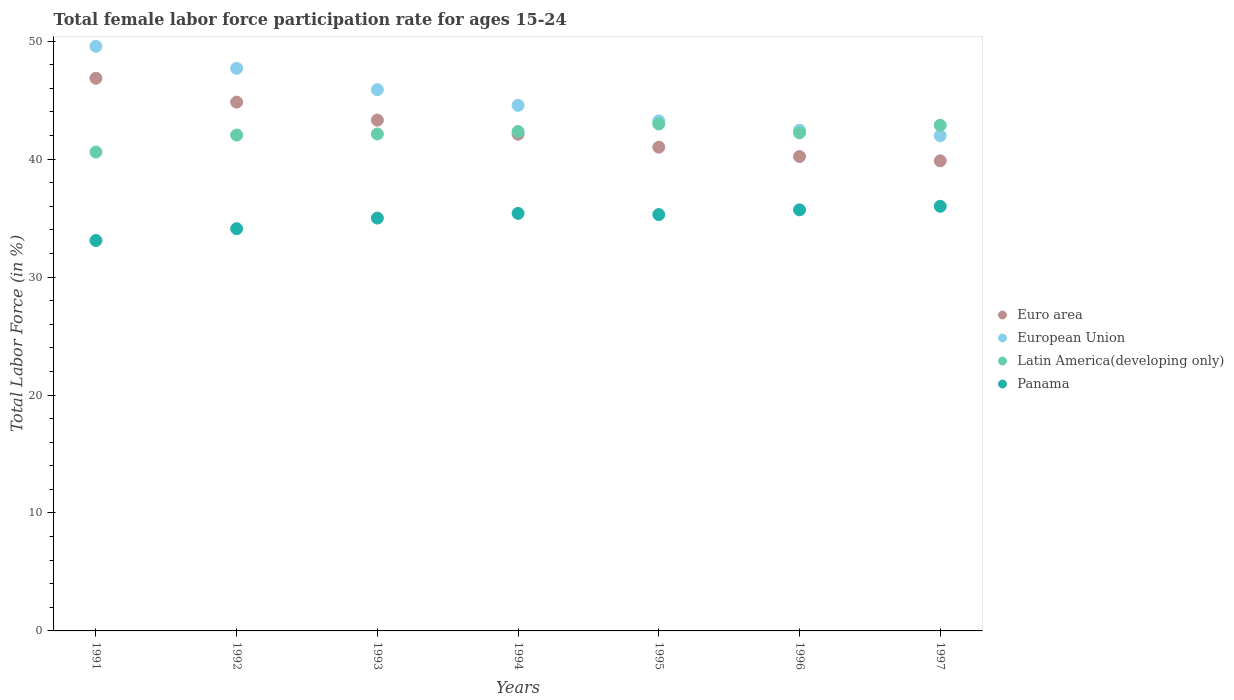How many different coloured dotlines are there?
Your answer should be compact. 4. What is the female labor force participation rate in Latin America(developing only) in 1994?
Your answer should be compact. 42.34. Across all years, what is the maximum female labor force participation rate in Panama?
Ensure brevity in your answer.  36. Across all years, what is the minimum female labor force participation rate in European Union?
Make the answer very short. 41.99. In which year was the female labor force participation rate in Latin America(developing only) maximum?
Offer a terse response. 1995. What is the total female labor force participation rate in Latin America(developing only) in the graph?
Offer a terse response. 295.19. What is the difference between the female labor force participation rate in Euro area in 1993 and that in 1995?
Provide a short and direct response. 2.3. What is the difference between the female labor force participation rate in Latin America(developing only) in 1992 and the female labor force participation rate in Panama in 1995?
Provide a short and direct response. 6.74. What is the average female labor force participation rate in Latin America(developing only) per year?
Ensure brevity in your answer.  42.17. In the year 1991, what is the difference between the female labor force participation rate in Euro area and female labor force participation rate in Panama?
Keep it short and to the point. 13.76. What is the ratio of the female labor force participation rate in Euro area in 1993 to that in 1994?
Offer a very short reply. 1.03. Is the difference between the female labor force participation rate in Euro area in 1992 and 1996 greater than the difference between the female labor force participation rate in Panama in 1992 and 1996?
Ensure brevity in your answer.  Yes. What is the difference between the highest and the second highest female labor force participation rate in Latin America(developing only)?
Provide a succinct answer. 0.11. What is the difference between the highest and the lowest female labor force participation rate in Latin America(developing only)?
Provide a short and direct response. 2.38. Is it the case that in every year, the sum of the female labor force participation rate in Latin America(developing only) and female labor force participation rate in Panama  is greater than the female labor force participation rate in European Union?
Make the answer very short. Yes. How many dotlines are there?
Your answer should be compact. 4. How many years are there in the graph?
Provide a succinct answer. 7. What is the difference between two consecutive major ticks on the Y-axis?
Give a very brief answer. 10. Does the graph contain grids?
Give a very brief answer. No. Where does the legend appear in the graph?
Provide a succinct answer. Center right. What is the title of the graph?
Offer a terse response. Total female labor force participation rate for ages 15-24. Does "Turkey" appear as one of the legend labels in the graph?
Your answer should be compact. No. What is the Total Labor Force (in %) in Euro area in 1991?
Your response must be concise. 46.86. What is the Total Labor Force (in %) in European Union in 1991?
Provide a short and direct response. 49.57. What is the Total Labor Force (in %) in Latin America(developing only) in 1991?
Ensure brevity in your answer.  40.6. What is the Total Labor Force (in %) in Panama in 1991?
Offer a terse response. 33.1. What is the Total Labor Force (in %) in Euro area in 1992?
Your answer should be very brief. 44.83. What is the Total Labor Force (in %) of European Union in 1992?
Give a very brief answer. 47.7. What is the Total Labor Force (in %) of Latin America(developing only) in 1992?
Keep it short and to the point. 42.04. What is the Total Labor Force (in %) in Panama in 1992?
Your answer should be very brief. 34.1. What is the Total Labor Force (in %) in Euro area in 1993?
Give a very brief answer. 43.31. What is the Total Labor Force (in %) of European Union in 1993?
Your answer should be compact. 45.89. What is the Total Labor Force (in %) of Latin America(developing only) in 1993?
Give a very brief answer. 42.13. What is the Total Labor Force (in %) in Euro area in 1994?
Offer a very short reply. 42.11. What is the Total Labor Force (in %) of European Union in 1994?
Provide a succinct answer. 44.56. What is the Total Labor Force (in %) in Latin America(developing only) in 1994?
Ensure brevity in your answer.  42.34. What is the Total Labor Force (in %) in Panama in 1994?
Make the answer very short. 35.4. What is the Total Labor Force (in %) of Euro area in 1995?
Provide a succinct answer. 41.01. What is the Total Labor Force (in %) of European Union in 1995?
Ensure brevity in your answer.  43.24. What is the Total Labor Force (in %) of Latin America(developing only) in 1995?
Give a very brief answer. 42.98. What is the Total Labor Force (in %) of Panama in 1995?
Keep it short and to the point. 35.3. What is the Total Labor Force (in %) in Euro area in 1996?
Your response must be concise. 40.22. What is the Total Labor Force (in %) in European Union in 1996?
Your answer should be very brief. 42.45. What is the Total Labor Force (in %) in Latin America(developing only) in 1996?
Offer a very short reply. 42.23. What is the Total Labor Force (in %) in Panama in 1996?
Offer a terse response. 35.7. What is the Total Labor Force (in %) of Euro area in 1997?
Provide a succinct answer. 39.86. What is the Total Labor Force (in %) of European Union in 1997?
Your answer should be compact. 41.99. What is the Total Labor Force (in %) of Latin America(developing only) in 1997?
Provide a short and direct response. 42.87. What is the Total Labor Force (in %) of Panama in 1997?
Provide a succinct answer. 36. Across all years, what is the maximum Total Labor Force (in %) of Euro area?
Ensure brevity in your answer.  46.86. Across all years, what is the maximum Total Labor Force (in %) of European Union?
Make the answer very short. 49.57. Across all years, what is the maximum Total Labor Force (in %) of Latin America(developing only)?
Your answer should be compact. 42.98. Across all years, what is the minimum Total Labor Force (in %) of Euro area?
Provide a short and direct response. 39.86. Across all years, what is the minimum Total Labor Force (in %) in European Union?
Make the answer very short. 41.99. Across all years, what is the minimum Total Labor Force (in %) in Latin America(developing only)?
Your answer should be compact. 40.6. Across all years, what is the minimum Total Labor Force (in %) in Panama?
Your answer should be very brief. 33.1. What is the total Total Labor Force (in %) in Euro area in the graph?
Keep it short and to the point. 298.19. What is the total Total Labor Force (in %) in European Union in the graph?
Make the answer very short. 315.39. What is the total Total Labor Force (in %) in Latin America(developing only) in the graph?
Ensure brevity in your answer.  295.19. What is the total Total Labor Force (in %) in Panama in the graph?
Give a very brief answer. 244.6. What is the difference between the Total Labor Force (in %) in Euro area in 1991 and that in 1992?
Provide a succinct answer. 2.02. What is the difference between the Total Labor Force (in %) in European Union in 1991 and that in 1992?
Your response must be concise. 1.87. What is the difference between the Total Labor Force (in %) of Latin America(developing only) in 1991 and that in 1992?
Your response must be concise. -1.44. What is the difference between the Total Labor Force (in %) in Euro area in 1991 and that in 1993?
Your response must be concise. 3.55. What is the difference between the Total Labor Force (in %) of European Union in 1991 and that in 1993?
Provide a succinct answer. 3.68. What is the difference between the Total Labor Force (in %) of Latin America(developing only) in 1991 and that in 1993?
Keep it short and to the point. -1.53. What is the difference between the Total Labor Force (in %) of Euro area in 1991 and that in 1994?
Your answer should be very brief. 4.74. What is the difference between the Total Labor Force (in %) in European Union in 1991 and that in 1994?
Keep it short and to the point. 5.01. What is the difference between the Total Labor Force (in %) of Latin America(developing only) in 1991 and that in 1994?
Provide a succinct answer. -1.74. What is the difference between the Total Labor Force (in %) of Panama in 1991 and that in 1994?
Provide a short and direct response. -2.3. What is the difference between the Total Labor Force (in %) in Euro area in 1991 and that in 1995?
Ensure brevity in your answer.  5.84. What is the difference between the Total Labor Force (in %) in European Union in 1991 and that in 1995?
Offer a very short reply. 6.33. What is the difference between the Total Labor Force (in %) of Latin America(developing only) in 1991 and that in 1995?
Offer a very short reply. -2.38. What is the difference between the Total Labor Force (in %) in Euro area in 1991 and that in 1996?
Keep it short and to the point. 6.64. What is the difference between the Total Labor Force (in %) in European Union in 1991 and that in 1996?
Your response must be concise. 7.11. What is the difference between the Total Labor Force (in %) of Latin America(developing only) in 1991 and that in 1996?
Offer a very short reply. -1.63. What is the difference between the Total Labor Force (in %) in Euro area in 1991 and that in 1997?
Offer a terse response. 7. What is the difference between the Total Labor Force (in %) of European Union in 1991 and that in 1997?
Your answer should be very brief. 7.58. What is the difference between the Total Labor Force (in %) of Latin America(developing only) in 1991 and that in 1997?
Give a very brief answer. -2.27. What is the difference between the Total Labor Force (in %) in Euro area in 1992 and that in 1993?
Your answer should be very brief. 1.52. What is the difference between the Total Labor Force (in %) of European Union in 1992 and that in 1993?
Offer a very short reply. 1.81. What is the difference between the Total Labor Force (in %) of Latin America(developing only) in 1992 and that in 1993?
Keep it short and to the point. -0.09. What is the difference between the Total Labor Force (in %) in Panama in 1992 and that in 1993?
Your response must be concise. -0.9. What is the difference between the Total Labor Force (in %) of Euro area in 1992 and that in 1994?
Ensure brevity in your answer.  2.72. What is the difference between the Total Labor Force (in %) in European Union in 1992 and that in 1994?
Ensure brevity in your answer.  3.14. What is the difference between the Total Labor Force (in %) of Latin America(developing only) in 1992 and that in 1994?
Make the answer very short. -0.3. What is the difference between the Total Labor Force (in %) of Panama in 1992 and that in 1994?
Your answer should be compact. -1.3. What is the difference between the Total Labor Force (in %) in Euro area in 1992 and that in 1995?
Your response must be concise. 3.82. What is the difference between the Total Labor Force (in %) of European Union in 1992 and that in 1995?
Give a very brief answer. 4.46. What is the difference between the Total Labor Force (in %) of Latin America(developing only) in 1992 and that in 1995?
Make the answer very short. -0.94. What is the difference between the Total Labor Force (in %) in Panama in 1992 and that in 1995?
Ensure brevity in your answer.  -1.2. What is the difference between the Total Labor Force (in %) in Euro area in 1992 and that in 1996?
Provide a short and direct response. 4.61. What is the difference between the Total Labor Force (in %) of European Union in 1992 and that in 1996?
Your response must be concise. 5.24. What is the difference between the Total Labor Force (in %) in Latin America(developing only) in 1992 and that in 1996?
Ensure brevity in your answer.  -0.19. What is the difference between the Total Labor Force (in %) in Panama in 1992 and that in 1996?
Your response must be concise. -1.6. What is the difference between the Total Labor Force (in %) of Euro area in 1992 and that in 1997?
Keep it short and to the point. 4.97. What is the difference between the Total Labor Force (in %) of European Union in 1992 and that in 1997?
Keep it short and to the point. 5.71. What is the difference between the Total Labor Force (in %) of Latin America(developing only) in 1992 and that in 1997?
Offer a very short reply. -0.83. What is the difference between the Total Labor Force (in %) in Euro area in 1993 and that in 1994?
Provide a short and direct response. 1.19. What is the difference between the Total Labor Force (in %) in European Union in 1993 and that in 1994?
Your answer should be compact. 1.33. What is the difference between the Total Labor Force (in %) in Latin America(developing only) in 1993 and that in 1994?
Your answer should be very brief. -0.21. What is the difference between the Total Labor Force (in %) in Panama in 1993 and that in 1994?
Offer a very short reply. -0.4. What is the difference between the Total Labor Force (in %) in Euro area in 1993 and that in 1995?
Keep it short and to the point. 2.29. What is the difference between the Total Labor Force (in %) of European Union in 1993 and that in 1995?
Offer a terse response. 2.65. What is the difference between the Total Labor Force (in %) of Latin America(developing only) in 1993 and that in 1995?
Give a very brief answer. -0.85. What is the difference between the Total Labor Force (in %) of Euro area in 1993 and that in 1996?
Provide a succinct answer. 3.09. What is the difference between the Total Labor Force (in %) of European Union in 1993 and that in 1996?
Provide a succinct answer. 3.43. What is the difference between the Total Labor Force (in %) in Latin America(developing only) in 1993 and that in 1996?
Keep it short and to the point. -0.1. What is the difference between the Total Labor Force (in %) in Euro area in 1993 and that in 1997?
Ensure brevity in your answer.  3.45. What is the difference between the Total Labor Force (in %) in European Union in 1993 and that in 1997?
Your answer should be very brief. 3.9. What is the difference between the Total Labor Force (in %) in Latin America(developing only) in 1993 and that in 1997?
Ensure brevity in your answer.  -0.74. What is the difference between the Total Labor Force (in %) of Panama in 1993 and that in 1997?
Your answer should be compact. -1. What is the difference between the Total Labor Force (in %) in Euro area in 1994 and that in 1995?
Offer a terse response. 1.1. What is the difference between the Total Labor Force (in %) of European Union in 1994 and that in 1995?
Your response must be concise. 1.32. What is the difference between the Total Labor Force (in %) of Latin America(developing only) in 1994 and that in 1995?
Your answer should be compact. -0.64. What is the difference between the Total Labor Force (in %) of Panama in 1994 and that in 1995?
Provide a succinct answer. 0.1. What is the difference between the Total Labor Force (in %) of Euro area in 1994 and that in 1996?
Provide a succinct answer. 1.9. What is the difference between the Total Labor Force (in %) of European Union in 1994 and that in 1996?
Provide a short and direct response. 2.11. What is the difference between the Total Labor Force (in %) in Latin America(developing only) in 1994 and that in 1996?
Provide a succinct answer. 0.11. What is the difference between the Total Labor Force (in %) in Panama in 1994 and that in 1996?
Provide a succinct answer. -0.3. What is the difference between the Total Labor Force (in %) of Euro area in 1994 and that in 1997?
Give a very brief answer. 2.26. What is the difference between the Total Labor Force (in %) of European Union in 1994 and that in 1997?
Offer a very short reply. 2.57. What is the difference between the Total Labor Force (in %) of Latin America(developing only) in 1994 and that in 1997?
Keep it short and to the point. -0.53. What is the difference between the Total Labor Force (in %) in Panama in 1994 and that in 1997?
Offer a terse response. -0.6. What is the difference between the Total Labor Force (in %) in Euro area in 1995 and that in 1996?
Offer a very short reply. 0.79. What is the difference between the Total Labor Force (in %) of European Union in 1995 and that in 1996?
Offer a very short reply. 0.79. What is the difference between the Total Labor Force (in %) in Latin America(developing only) in 1995 and that in 1996?
Give a very brief answer. 0.75. What is the difference between the Total Labor Force (in %) in Euro area in 1995 and that in 1997?
Ensure brevity in your answer.  1.15. What is the difference between the Total Labor Force (in %) in European Union in 1995 and that in 1997?
Your answer should be compact. 1.25. What is the difference between the Total Labor Force (in %) in Latin America(developing only) in 1995 and that in 1997?
Keep it short and to the point. 0.11. What is the difference between the Total Labor Force (in %) of Panama in 1995 and that in 1997?
Give a very brief answer. -0.7. What is the difference between the Total Labor Force (in %) in Euro area in 1996 and that in 1997?
Offer a very short reply. 0.36. What is the difference between the Total Labor Force (in %) in European Union in 1996 and that in 1997?
Offer a terse response. 0.46. What is the difference between the Total Labor Force (in %) of Latin America(developing only) in 1996 and that in 1997?
Your answer should be very brief. -0.64. What is the difference between the Total Labor Force (in %) of Euro area in 1991 and the Total Labor Force (in %) of European Union in 1992?
Provide a succinct answer. -0.84. What is the difference between the Total Labor Force (in %) in Euro area in 1991 and the Total Labor Force (in %) in Latin America(developing only) in 1992?
Offer a terse response. 4.82. What is the difference between the Total Labor Force (in %) of Euro area in 1991 and the Total Labor Force (in %) of Panama in 1992?
Provide a short and direct response. 12.76. What is the difference between the Total Labor Force (in %) of European Union in 1991 and the Total Labor Force (in %) of Latin America(developing only) in 1992?
Ensure brevity in your answer.  7.53. What is the difference between the Total Labor Force (in %) in European Union in 1991 and the Total Labor Force (in %) in Panama in 1992?
Ensure brevity in your answer.  15.47. What is the difference between the Total Labor Force (in %) in Latin America(developing only) in 1991 and the Total Labor Force (in %) in Panama in 1992?
Make the answer very short. 6.5. What is the difference between the Total Labor Force (in %) of Euro area in 1991 and the Total Labor Force (in %) of European Union in 1993?
Your response must be concise. 0.97. What is the difference between the Total Labor Force (in %) in Euro area in 1991 and the Total Labor Force (in %) in Latin America(developing only) in 1993?
Your response must be concise. 4.72. What is the difference between the Total Labor Force (in %) of Euro area in 1991 and the Total Labor Force (in %) of Panama in 1993?
Your response must be concise. 11.86. What is the difference between the Total Labor Force (in %) of European Union in 1991 and the Total Labor Force (in %) of Latin America(developing only) in 1993?
Offer a terse response. 7.43. What is the difference between the Total Labor Force (in %) of European Union in 1991 and the Total Labor Force (in %) of Panama in 1993?
Make the answer very short. 14.57. What is the difference between the Total Labor Force (in %) of Latin America(developing only) in 1991 and the Total Labor Force (in %) of Panama in 1993?
Offer a terse response. 5.6. What is the difference between the Total Labor Force (in %) of Euro area in 1991 and the Total Labor Force (in %) of European Union in 1994?
Your answer should be very brief. 2.3. What is the difference between the Total Labor Force (in %) of Euro area in 1991 and the Total Labor Force (in %) of Latin America(developing only) in 1994?
Offer a terse response. 4.52. What is the difference between the Total Labor Force (in %) of Euro area in 1991 and the Total Labor Force (in %) of Panama in 1994?
Give a very brief answer. 11.46. What is the difference between the Total Labor Force (in %) of European Union in 1991 and the Total Labor Force (in %) of Latin America(developing only) in 1994?
Give a very brief answer. 7.23. What is the difference between the Total Labor Force (in %) in European Union in 1991 and the Total Labor Force (in %) in Panama in 1994?
Offer a terse response. 14.17. What is the difference between the Total Labor Force (in %) in Latin America(developing only) in 1991 and the Total Labor Force (in %) in Panama in 1994?
Provide a succinct answer. 5.2. What is the difference between the Total Labor Force (in %) of Euro area in 1991 and the Total Labor Force (in %) of European Union in 1995?
Your response must be concise. 3.62. What is the difference between the Total Labor Force (in %) of Euro area in 1991 and the Total Labor Force (in %) of Latin America(developing only) in 1995?
Give a very brief answer. 3.88. What is the difference between the Total Labor Force (in %) of Euro area in 1991 and the Total Labor Force (in %) of Panama in 1995?
Offer a terse response. 11.56. What is the difference between the Total Labor Force (in %) in European Union in 1991 and the Total Labor Force (in %) in Latin America(developing only) in 1995?
Your answer should be very brief. 6.59. What is the difference between the Total Labor Force (in %) of European Union in 1991 and the Total Labor Force (in %) of Panama in 1995?
Ensure brevity in your answer.  14.27. What is the difference between the Total Labor Force (in %) in Latin America(developing only) in 1991 and the Total Labor Force (in %) in Panama in 1995?
Provide a short and direct response. 5.3. What is the difference between the Total Labor Force (in %) in Euro area in 1991 and the Total Labor Force (in %) in European Union in 1996?
Give a very brief answer. 4.4. What is the difference between the Total Labor Force (in %) of Euro area in 1991 and the Total Labor Force (in %) of Latin America(developing only) in 1996?
Provide a short and direct response. 4.62. What is the difference between the Total Labor Force (in %) in Euro area in 1991 and the Total Labor Force (in %) in Panama in 1996?
Make the answer very short. 11.16. What is the difference between the Total Labor Force (in %) in European Union in 1991 and the Total Labor Force (in %) in Latin America(developing only) in 1996?
Your answer should be very brief. 7.33. What is the difference between the Total Labor Force (in %) of European Union in 1991 and the Total Labor Force (in %) of Panama in 1996?
Your answer should be compact. 13.87. What is the difference between the Total Labor Force (in %) of Latin America(developing only) in 1991 and the Total Labor Force (in %) of Panama in 1996?
Provide a short and direct response. 4.9. What is the difference between the Total Labor Force (in %) in Euro area in 1991 and the Total Labor Force (in %) in European Union in 1997?
Offer a very short reply. 4.87. What is the difference between the Total Labor Force (in %) in Euro area in 1991 and the Total Labor Force (in %) in Latin America(developing only) in 1997?
Offer a terse response. 3.98. What is the difference between the Total Labor Force (in %) of Euro area in 1991 and the Total Labor Force (in %) of Panama in 1997?
Your response must be concise. 10.86. What is the difference between the Total Labor Force (in %) in European Union in 1991 and the Total Labor Force (in %) in Latin America(developing only) in 1997?
Provide a succinct answer. 6.7. What is the difference between the Total Labor Force (in %) of European Union in 1991 and the Total Labor Force (in %) of Panama in 1997?
Offer a terse response. 13.57. What is the difference between the Total Labor Force (in %) of Latin America(developing only) in 1991 and the Total Labor Force (in %) of Panama in 1997?
Provide a short and direct response. 4.6. What is the difference between the Total Labor Force (in %) in Euro area in 1992 and the Total Labor Force (in %) in European Union in 1993?
Ensure brevity in your answer.  -1.06. What is the difference between the Total Labor Force (in %) in Euro area in 1992 and the Total Labor Force (in %) in Latin America(developing only) in 1993?
Ensure brevity in your answer.  2.7. What is the difference between the Total Labor Force (in %) of Euro area in 1992 and the Total Labor Force (in %) of Panama in 1993?
Your answer should be very brief. 9.83. What is the difference between the Total Labor Force (in %) in European Union in 1992 and the Total Labor Force (in %) in Latin America(developing only) in 1993?
Your response must be concise. 5.56. What is the difference between the Total Labor Force (in %) of European Union in 1992 and the Total Labor Force (in %) of Panama in 1993?
Keep it short and to the point. 12.7. What is the difference between the Total Labor Force (in %) in Latin America(developing only) in 1992 and the Total Labor Force (in %) in Panama in 1993?
Give a very brief answer. 7.04. What is the difference between the Total Labor Force (in %) in Euro area in 1992 and the Total Labor Force (in %) in European Union in 1994?
Give a very brief answer. 0.27. What is the difference between the Total Labor Force (in %) in Euro area in 1992 and the Total Labor Force (in %) in Latin America(developing only) in 1994?
Offer a very short reply. 2.49. What is the difference between the Total Labor Force (in %) in Euro area in 1992 and the Total Labor Force (in %) in Panama in 1994?
Make the answer very short. 9.43. What is the difference between the Total Labor Force (in %) in European Union in 1992 and the Total Labor Force (in %) in Latin America(developing only) in 1994?
Make the answer very short. 5.36. What is the difference between the Total Labor Force (in %) in European Union in 1992 and the Total Labor Force (in %) in Panama in 1994?
Provide a short and direct response. 12.3. What is the difference between the Total Labor Force (in %) of Latin America(developing only) in 1992 and the Total Labor Force (in %) of Panama in 1994?
Offer a very short reply. 6.64. What is the difference between the Total Labor Force (in %) of Euro area in 1992 and the Total Labor Force (in %) of European Union in 1995?
Your answer should be compact. 1.59. What is the difference between the Total Labor Force (in %) of Euro area in 1992 and the Total Labor Force (in %) of Latin America(developing only) in 1995?
Offer a very short reply. 1.85. What is the difference between the Total Labor Force (in %) in Euro area in 1992 and the Total Labor Force (in %) in Panama in 1995?
Your answer should be very brief. 9.53. What is the difference between the Total Labor Force (in %) in European Union in 1992 and the Total Labor Force (in %) in Latin America(developing only) in 1995?
Your response must be concise. 4.72. What is the difference between the Total Labor Force (in %) of European Union in 1992 and the Total Labor Force (in %) of Panama in 1995?
Provide a short and direct response. 12.4. What is the difference between the Total Labor Force (in %) of Latin America(developing only) in 1992 and the Total Labor Force (in %) of Panama in 1995?
Give a very brief answer. 6.74. What is the difference between the Total Labor Force (in %) in Euro area in 1992 and the Total Labor Force (in %) in European Union in 1996?
Your answer should be very brief. 2.38. What is the difference between the Total Labor Force (in %) in Euro area in 1992 and the Total Labor Force (in %) in Latin America(developing only) in 1996?
Offer a terse response. 2.6. What is the difference between the Total Labor Force (in %) in Euro area in 1992 and the Total Labor Force (in %) in Panama in 1996?
Your answer should be compact. 9.13. What is the difference between the Total Labor Force (in %) in European Union in 1992 and the Total Labor Force (in %) in Latin America(developing only) in 1996?
Offer a very short reply. 5.46. What is the difference between the Total Labor Force (in %) in European Union in 1992 and the Total Labor Force (in %) in Panama in 1996?
Offer a very short reply. 12. What is the difference between the Total Labor Force (in %) of Latin America(developing only) in 1992 and the Total Labor Force (in %) of Panama in 1996?
Ensure brevity in your answer.  6.34. What is the difference between the Total Labor Force (in %) of Euro area in 1992 and the Total Labor Force (in %) of European Union in 1997?
Your answer should be compact. 2.84. What is the difference between the Total Labor Force (in %) of Euro area in 1992 and the Total Labor Force (in %) of Latin America(developing only) in 1997?
Provide a short and direct response. 1.96. What is the difference between the Total Labor Force (in %) in Euro area in 1992 and the Total Labor Force (in %) in Panama in 1997?
Make the answer very short. 8.83. What is the difference between the Total Labor Force (in %) of European Union in 1992 and the Total Labor Force (in %) of Latin America(developing only) in 1997?
Give a very brief answer. 4.83. What is the difference between the Total Labor Force (in %) in European Union in 1992 and the Total Labor Force (in %) in Panama in 1997?
Your answer should be compact. 11.7. What is the difference between the Total Labor Force (in %) of Latin America(developing only) in 1992 and the Total Labor Force (in %) of Panama in 1997?
Your answer should be very brief. 6.04. What is the difference between the Total Labor Force (in %) of Euro area in 1993 and the Total Labor Force (in %) of European Union in 1994?
Your response must be concise. -1.25. What is the difference between the Total Labor Force (in %) in Euro area in 1993 and the Total Labor Force (in %) in Latin America(developing only) in 1994?
Provide a short and direct response. 0.97. What is the difference between the Total Labor Force (in %) of Euro area in 1993 and the Total Labor Force (in %) of Panama in 1994?
Keep it short and to the point. 7.91. What is the difference between the Total Labor Force (in %) in European Union in 1993 and the Total Labor Force (in %) in Latin America(developing only) in 1994?
Make the answer very short. 3.55. What is the difference between the Total Labor Force (in %) in European Union in 1993 and the Total Labor Force (in %) in Panama in 1994?
Provide a short and direct response. 10.49. What is the difference between the Total Labor Force (in %) of Latin America(developing only) in 1993 and the Total Labor Force (in %) of Panama in 1994?
Your answer should be very brief. 6.73. What is the difference between the Total Labor Force (in %) of Euro area in 1993 and the Total Labor Force (in %) of European Union in 1995?
Make the answer very short. 0.07. What is the difference between the Total Labor Force (in %) of Euro area in 1993 and the Total Labor Force (in %) of Latin America(developing only) in 1995?
Provide a succinct answer. 0.33. What is the difference between the Total Labor Force (in %) in Euro area in 1993 and the Total Labor Force (in %) in Panama in 1995?
Your answer should be very brief. 8.01. What is the difference between the Total Labor Force (in %) in European Union in 1993 and the Total Labor Force (in %) in Latin America(developing only) in 1995?
Offer a very short reply. 2.91. What is the difference between the Total Labor Force (in %) in European Union in 1993 and the Total Labor Force (in %) in Panama in 1995?
Ensure brevity in your answer.  10.59. What is the difference between the Total Labor Force (in %) of Latin America(developing only) in 1993 and the Total Labor Force (in %) of Panama in 1995?
Give a very brief answer. 6.83. What is the difference between the Total Labor Force (in %) of Euro area in 1993 and the Total Labor Force (in %) of European Union in 1996?
Provide a short and direct response. 0.85. What is the difference between the Total Labor Force (in %) of Euro area in 1993 and the Total Labor Force (in %) of Latin America(developing only) in 1996?
Your response must be concise. 1.07. What is the difference between the Total Labor Force (in %) of Euro area in 1993 and the Total Labor Force (in %) of Panama in 1996?
Provide a succinct answer. 7.61. What is the difference between the Total Labor Force (in %) in European Union in 1993 and the Total Labor Force (in %) in Latin America(developing only) in 1996?
Your response must be concise. 3.65. What is the difference between the Total Labor Force (in %) of European Union in 1993 and the Total Labor Force (in %) of Panama in 1996?
Provide a short and direct response. 10.19. What is the difference between the Total Labor Force (in %) in Latin America(developing only) in 1993 and the Total Labor Force (in %) in Panama in 1996?
Offer a very short reply. 6.43. What is the difference between the Total Labor Force (in %) in Euro area in 1993 and the Total Labor Force (in %) in European Union in 1997?
Make the answer very short. 1.32. What is the difference between the Total Labor Force (in %) of Euro area in 1993 and the Total Labor Force (in %) of Latin America(developing only) in 1997?
Provide a short and direct response. 0.44. What is the difference between the Total Labor Force (in %) in Euro area in 1993 and the Total Labor Force (in %) in Panama in 1997?
Give a very brief answer. 7.31. What is the difference between the Total Labor Force (in %) in European Union in 1993 and the Total Labor Force (in %) in Latin America(developing only) in 1997?
Your answer should be very brief. 3.02. What is the difference between the Total Labor Force (in %) in European Union in 1993 and the Total Labor Force (in %) in Panama in 1997?
Keep it short and to the point. 9.89. What is the difference between the Total Labor Force (in %) in Latin America(developing only) in 1993 and the Total Labor Force (in %) in Panama in 1997?
Your answer should be compact. 6.13. What is the difference between the Total Labor Force (in %) of Euro area in 1994 and the Total Labor Force (in %) of European Union in 1995?
Make the answer very short. -1.12. What is the difference between the Total Labor Force (in %) in Euro area in 1994 and the Total Labor Force (in %) in Latin America(developing only) in 1995?
Keep it short and to the point. -0.87. What is the difference between the Total Labor Force (in %) in Euro area in 1994 and the Total Labor Force (in %) in Panama in 1995?
Offer a terse response. 6.81. What is the difference between the Total Labor Force (in %) of European Union in 1994 and the Total Labor Force (in %) of Latin America(developing only) in 1995?
Offer a terse response. 1.58. What is the difference between the Total Labor Force (in %) of European Union in 1994 and the Total Labor Force (in %) of Panama in 1995?
Ensure brevity in your answer.  9.26. What is the difference between the Total Labor Force (in %) in Latin America(developing only) in 1994 and the Total Labor Force (in %) in Panama in 1995?
Ensure brevity in your answer.  7.04. What is the difference between the Total Labor Force (in %) in Euro area in 1994 and the Total Labor Force (in %) in European Union in 1996?
Keep it short and to the point. -0.34. What is the difference between the Total Labor Force (in %) in Euro area in 1994 and the Total Labor Force (in %) in Latin America(developing only) in 1996?
Provide a succinct answer. -0.12. What is the difference between the Total Labor Force (in %) of Euro area in 1994 and the Total Labor Force (in %) of Panama in 1996?
Offer a very short reply. 6.41. What is the difference between the Total Labor Force (in %) in European Union in 1994 and the Total Labor Force (in %) in Latin America(developing only) in 1996?
Your answer should be compact. 2.33. What is the difference between the Total Labor Force (in %) of European Union in 1994 and the Total Labor Force (in %) of Panama in 1996?
Ensure brevity in your answer.  8.86. What is the difference between the Total Labor Force (in %) of Latin America(developing only) in 1994 and the Total Labor Force (in %) of Panama in 1996?
Provide a succinct answer. 6.64. What is the difference between the Total Labor Force (in %) in Euro area in 1994 and the Total Labor Force (in %) in European Union in 1997?
Your response must be concise. 0.12. What is the difference between the Total Labor Force (in %) in Euro area in 1994 and the Total Labor Force (in %) in Latin America(developing only) in 1997?
Offer a very short reply. -0.76. What is the difference between the Total Labor Force (in %) in Euro area in 1994 and the Total Labor Force (in %) in Panama in 1997?
Your answer should be compact. 6.11. What is the difference between the Total Labor Force (in %) in European Union in 1994 and the Total Labor Force (in %) in Latin America(developing only) in 1997?
Ensure brevity in your answer.  1.69. What is the difference between the Total Labor Force (in %) in European Union in 1994 and the Total Labor Force (in %) in Panama in 1997?
Offer a very short reply. 8.56. What is the difference between the Total Labor Force (in %) of Latin America(developing only) in 1994 and the Total Labor Force (in %) of Panama in 1997?
Offer a terse response. 6.34. What is the difference between the Total Labor Force (in %) in Euro area in 1995 and the Total Labor Force (in %) in European Union in 1996?
Provide a short and direct response. -1.44. What is the difference between the Total Labor Force (in %) of Euro area in 1995 and the Total Labor Force (in %) of Latin America(developing only) in 1996?
Keep it short and to the point. -1.22. What is the difference between the Total Labor Force (in %) in Euro area in 1995 and the Total Labor Force (in %) in Panama in 1996?
Make the answer very short. 5.31. What is the difference between the Total Labor Force (in %) of European Union in 1995 and the Total Labor Force (in %) of Latin America(developing only) in 1996?
Make the answer very short. 1.01. What is the difference between the Total Labor Force (in %) of European Union in 1995 and the Total Labor Force (in %) of Panama in 1996?
Keep it short and to the point. 7.54. What is the difference between the Total Labor Force (in %) in Latin America(developing only) in 1995 and the Total Labor Force (in %) in Panama in 1996?
Your response must be concise. 7.28. What is the difference between the Total Labor Force (in %) of Euro area in 1995 and the Total Labor Force (in %) of European Union in 1997?
Make the answer very short. -0.98. What is the difference between the Total Labor Force (in %) in Euro area in 1995 and the Total Labor Force (in %) in Latin America(developing only) in 1997?
Your response must be concise. -1.86. What is the difference between the Total Labor Force (in %) of Euro area in 1995 and the Total Labor Force (in %) of Panama in 1997?
Your answer should be compact. 5.01. What is the difference between the Total Labor Force (in %) in European Union in 1995 and the Total Labor Force (in %) in Latin America(developing only) in 1997?
Give a very brief answer. 0.37. What is the difference between the Total Labor Force (in %) in European Union in 1995 and the Total Labor Force (in %) in Panama in 1997?
Your answer should be very brief. 7.24. What is the difference between the Total Labor Force (in %) in Latin America(developing only) in 1995 and the Total Labor Force (in %) in Panama in 1997?
Offer a terse response. 6.98. What is the difference between the Total Labor Force (in %) in Euro area in 1996 and the Total Labor Force (in %) in European Union in 1997?
Ensure brevity in your answer.  -1.77. What is the difference between the Total Labor Force (in %) in Euro area in 1996 and the Total Labor Force (in %) in Latin America(developing only) in 1997?
Offer a terse response. -2.65. What is the difference between the Total Labor Force (in %) of Euro area in 1996 and the Total Labor Force (in %) of Panama in 1997?
Provide a succinct answer. 4.22. What is the difference between the Total Labor Force (in %) of European Union in 1996 and the Total Labor Force (in %) of Latin America(developing only) in 1997?
Provide a succinct answer. -0.42. What is the difference between the Total Labor Force (in %) of European Union in 1996 and the Total Labor Force (in %) of Panama in 1997?
Offer a very short reply. 6.45. What is the difference between the Total Labor Force (in %) of Latin America(developing only) in 1996 and the Total Labor Force (in %) of Panama in 1997?
Ensure brevity in your answer.  6.23. What is the average Total Labor Force (in %) of Euro area per year?
Give a very brief answer. 42.6. What is the average Total Labor Force (in %) of European Union per year?
Make the answer very short. 45.06. What is the average Total Labor Force (in %) in Latin America(developing only) per year?
Your answer should be compact. 42.17. What is the average Total Labor Force (in %) of Panama per year?
Offer a very short reply. 34.94. In the year 1991, what is the difference between the Total Labor Force (in %) of Euro area and Total Labor Force (in %) of European Union?
Provide a short and direct response. -2.71. In the year 1991, what is the difference between the Total Labor Force (in %) of Euro area and Total Labor Force (in %) of Latin America(developing only)?
Your answer should be very brief. 6.26. In the year 1991, what is the difference between the Total Labor Force (in %) in Euro area and Total Labor Force (in %) in Panama?
Your answer should be very brief. 13.76. In the year 1991, what is the difference between the Total Labor Force (in %) of European Union and Total Labor Force (in %) of Latin America(developing only)?
Make the answer very short. 8.97. In the year 1991, what is the difference between the Total Labor Force (in %) of European Union and Total Labor Force (in %) of Panama?
Keep it short and to the point. 16.47. In the year 1991, what is the difference between the Total Labor Force (in %) of Latin America(developing only) and Total Labor Force (in %) of Panama?
Give a very brief answer. 7.5. In the year 1992, what is the difference between the Total Labor Force (in %) in Euro area and Total Labor Force (in %) in European Union?
Give a very brief answer. -2.87. In the year 1992, what is the difference between the Total Labor Force (in %) in Euro area and Total Labor Force (in %) in Latin America(developing only)?
Provide a short and direct response. 2.79. In the year 1992, what is the difference between the Total Labor Force (in %) in Euro area and Total Labor Force (in %) in Panama?
Make the answer very short. 10.73. In the year 1992, what is the difference between the Total Labor Force (in %) of European Union and Total Labor Force (in %) of Latin America(developing only)?
Give a very brief answer. 5.66. In the year 1992, what is the difference between the Total Labor Force (in %) in European Union and Total Labor Force (in %) in Panama?
Provide a short and direct response. 13.6. In the year 1992, what is the difference between the Total Labor Force (in %) of Latin America(developing only) and Total Labor Force (in %) of Panama?
Give a very brief answer. 7.94. In the year 1993, what is the difference between the Total Labor Force (in %) in Euro area and Total Labor Force (in %) in European Union?
Your response must be concise. -2.58. In the year 1993, what is the difference between the Total Labor Force (in %) in Euro area and Total Labor Force (in %) in Latin America(developing only)?
Make the answer very short. 1.17. In the year 1993, what is the difference between the Total Labor Force (in %) in Euro area and Total Labor Force (in %) in Panama?
Keep it short and to the point. 8.31. In the year 1993, what is the difference between the Total Labor Force (in %) of European Union and Total Labor Force (in %) of Latin America(developing only)?
Your answer should be very brief. 3.75. In the year 1993, what is the difference between the Total Labor Force (in %) of European Union and Total Labor Force (in %) of Panama?
Provide a succinct answer. 10.89. In the year 1993, what is the difference between the Total Labor Force (in %) of Latin America(developing only) and Total Labor Force (in %) of Panama?
Your answer should be compact. 7.13. In the year 1994, what is the difference between the Total Labor Force (in %) in Euro area and Total Labor Force (in %) in European Union?
Your response must be concise. -2.44. In the year 1994, what is the difference between the Total Labor Force (in %) of Euro area and Total Labor Force (in %) of Latin America(developing only)?
Your response must be concise. -0.23. In the year 1994, what is the difference between the Total Labor Force (in %) in Euro area and Total Labor Force (in %) in Panama?
Keep it short and to the point. 6.71. In the year 1994, what is the difference between the Total Labor Force (in %) of European Union and Total Labor Force (in %) of Latin America(developing only)?
Your answer should be compact. 2.22. In the year 1994, what is the difference between the Total Labor Force (in %) of European Union and Total Labor Force (in %) of Panama?
Keep it short and to the point. 9.16. In the year 1994, what is the difference between the Total Labor Force (in %) of Latin America(developing only) and Total Labor Force (in %) of Panama?
Offer a terse response. 6.94. In the year 1995, what is the difference between the Total Labor Force (in %) of Euro area and Total Labor Force (in %) of European Union?
Your answer should be very brief. -2.23. In the year 1995, what is the difference between the Total Labor Force (in %) of Euro area and Total Labor Force (in %) of Latin America(developing only)?
Give a very brief answer. -1.97. In the year 1995, what is the difference between the Total Labor Force (in %) of Euro area and Total Labor Force (in %) of Panama?
Give a very brief answer. 5.71. In the year 1995, what is the difference between the Total Labor Force (in %) of European Union and Total Labor Force (in %) of Latin America(developing only)?
Give a very brief answer. 0.26. In the year 1995, what is the difference between the Total Labor Force (in %) of European Union and Total Labor Force (in %) of Panama?
Ensure brevity in your answer.  7.94. In the year 1995, what is the difference between the Total Labor Force (in %) in Latin America(developing only) and Total Labor Force (in %) in Panama?
Your answer should be compact. 7.68. In the year 1996, what is the difference between the Total Labor Force (in %) of Euro area and Total Labor Force (in %) of European Union?
Keep it short and to the point. -2.24. In the year 1996, what is the difference between the Total Labor Force (in %) of Euro area and Total Labor Force (in %) of Latin America(developing only)?
Offer a very short reply. -2.01. In the year 1996, what is the difference between the Total Labor Force (in %) of Euro area and Total Labor Force (in %) of Panama?
Offer a very short reply. 4.52. In the year 1996, what is the difference between the Total Labor Force (in %) in European Union and Total Labor Force (in %) in Latin America(developing only)?
Offer a terse response. 0.22. In the year 1996, what is the difference between the Total Labor Force (in %) in European Union and Total Labor Force (in %) in Panama?
Your response must be concise. 6.75. In the year 1996, what is the difference between the Total Labor Force (in %) of Latin America(developing only) and Total Labor Force (in %) of Panama?
Ensure brevity in your answer.  6.53. In the year 1997, what is the difference between the Total Labor Force (in %) in Euro area and Total Labor Force (in %) in European Union?
Ensure brevity in your answer.  -2.13. In the year 1997, what is the difference between the Total Labor Force (in %) in Euro area and Total Labor Force (in %) in Latin America(developing only)?
Keep it short and to the point. -3.01. In the year 1997, what is the difference between the Total Labor Force (in %) in Euro area and Total Labor Force (in %) in Panama?
Provide a short and direct response. 3.86. In the year 1997, what is the difference between the Total Labor Force (in %) in European Union and Total Labor Force (in %) in Latin America(developing only)?
Give a very brief answer. -0.88. In the year 1997, what is the difference between the Total Labor Force (in %) in European Union and Total Labor Force (in %) in Panama?
Offer a terse response. 5.99. In the year 1997, what is the difference between the Total Labor Force (in %) in Latin America(developing only) and Total Labor Force (in %) in Panama?
Provide a succinct answer. 6.87. What is the ratio of the Total Labor Force (in %) in Euro area in 1991 to that in 1992?
Keep it short and to the point. 1.05. What is the ratio of the Total Labor Force (in %) in European Union in 1991 to that in 1992?
Keep it short and to the point. 1.04. What is the ratio of the Total Labor Force (in %) in Latin America(developing only) in 1991 to that in 1992?
Keep it short and to the point. 0.97. What is the ratio of the Total Labor Force (in %) in Panama in 1991 to that in 1992?
Offer a terse response. 0.97. What is the ratio of the Total Labor Force (in %) in Euro area in 1991 to that in 1993?
Make the answer very short. 1.08. What is the ratio of the Total Labor Force (in %) in European Union in 1991 to that in 1993?
Keep it short and to the point. 1.08. What is the ratio of the Total Labor Force (in %) in Latin America(developing only) in 1991 to that in 1993?
Offer a very short reply. 0.96. What is the ratio of the Total Labor Force (in %) of Panama in 1991 to that in 1993?
Offer a very short reply. 0.95. What is the ratio of the Total Labor Force (in %) of Euro area in 1991 to that in 1994?
Give a very brief answer. 1.11. What is the ratio of the Total Labor Force (in %) of European Union in 1991 to that in 1994?
Offer a very short reply. 1.11. What is the ratio of the Total Labor Force (in %) of Latin America(developing only) in 1991 to that in 1994?
Your answer should be compact. 0.96. What is the ratio of the Total Labor Force (in %) of Panama in 1991 to that in 1994?
Provide a succinct answer. 0.94. What is the ratio of the Total Labor Force (in %) in Euro area in 1991 to that in 1995?
Give a very brief answer. 1.14. What is the ratio of the Total Labor Force (in %) in European Union in 1991 to that in 1995?
Keep it short and to the point. 1.15. What is the ratio of the Total Labor Force (in %) in Latin America(developing only) in 1991 to that in 1995?
Your response must be concise. 0.94. What is the ratio of the Total Labor Force (in %) of Panama in 1991 to that in 1995?
Provide a succinct answer. 0.94. What is the ratio of the Total Labor Force (in %) in Euro area in 1991 to that in 1996?
Make the answer very short. 1.17. What is the ratio of the Total Labor Force (in %) in European Union in 1991 to that in 1996?
Give a very brief answer. 1.17. What is the ratio of the Total Labor Force (in %) in Latin America(developing only) in 1991 to that in 1996?
Provide a short and direct response. 0.96. What is the ratio of the Total Labor Force (in %) of Panama in 1991 to that in 1996?
Keep it short and to the point. 0.93. What is the ratio of the Total Labor Force (in %) in Euro area in 1991 to that in 1997?
Your answer should be very brief. 1.18. What is the ratio of the Total Labor Force (in %) in European Union in 1991 to that in 1997?
Offer a very short reply. 1.18. What is the ratio of the Total Labor Force (in %) in Latin America(developing only) in 1991 to that in 1997?
Make the answer very short. 0.95. What is the ratio of the Total Labor Force (in %) in Panama in 1991 to that in 1997?
Offer a very short reply. 0.92. What is the ratio of the Total Labor Force (in %) of Euro area in 1992 to that in 1993?
Your response must be concise. 1.04. What is the ratio of the Total Labor Force (in %) in European Union in 1992 to that in 1993?
Make the answer very short. 1.04. What is the ratio of the Total Labor Force (in %) in Latin America(developing only) in 1992 to that in 1993?
Your response must be concise. 1. What is the ratio of the Total Labor Force (in %) of Panama in 1992 to that in 1993?
Ensure brevity in your answer.  0.97. What is the ratio of the Total Labor Force (in %) in Euro area in 1992 to that in 1994?
Provide a short and direct response. 1.06. What is the ratio of the Total Labor Force (in %) in European Union in 1992 to that in 1994?
Your answer should be very brief. 1.07. What is the ratio of the Total Labor Force (in %) of Latin America(developing only) in 1992 to that in 1994?
Provide a succinct answer. 0.99. What is the ratio of the Total Labor Force (in %) of Panama in 1992 to that in 1994?
Ensure brevity in your answer.  0.96. What is the ratio of the Total Labor Force (in %) of Euro area in 1992 to that in 1995?
Your answer should be compact. 1.09. What is the ratio of the Total Labor Force (in %) in European Union in 1992 to that in 1995?
Give a very brief answer. 1.1. What is the ratio of the Total Labor Force (in %) in Latin America(developing only) in 1992 to that in 1995?
Ensure brevity in your answer.  0.98. What is the ratio of the Total Labor Force (in %) in Panama in 1992 to that in 1995?
Make the answer very short. 0.97. What is the ratio of the Total Labor Force (in %) of Euro area in 1992 to that in 1996?
Give a very brief answer. 1.11. What is the ratio of the Total Labor Force (in %) of European Union in 1992 to that in 1996?
Offer a very short reply. 1.12. What is the ratio of the Total Labor Force (in %) of Panama in 1992 to that in 1996?
Offer a very short reply. 0.96. What is the ratio of the Total Labor Force (in %) of Euro area in 1992 to that in 1997?
Offer a terse response. 1.12. What is the ratio of the Total Labor Force (in %) of European Union in 1992 to that in 1997?
Provide a succinct answer. 1.14. What is the ratio of the Total Labor Force (in %) of Latin America(developing only) in 1992 to that in 1997?
Give a very brief answer. 0.98. What is the ratio of the Total Labor Force (in %) in Panama in 1992 to that in 1997?
Your answer should be very brief. 0.95. What is the ratio of the Total Labor Force (in %) of Euro area in 1993 to that in 1994?
Offer a very short reply. 1.03. What is the ratio of the Total Labor Force (in %) of European Union in 1993 to that in 1994?
Your response must be concise. 1.03. What is the ratio of the Total Labor Force (in %) in Latin America(developing only) in 1993 to that in 1994?
Give a very brief answer. 1. What is the ratio of the Total Labor Force (in %) of Panama in 1993 to that in 1994?
Your response must be concise. 0.99. What is the ratio of the Total Labor Force (in %) of Euro area in 1993 to that in 1995?
Keep it short and to the point. 1.06. What is the ratio of the Total Labor Force (in %) of European Union in 1993 to that in 1995?
Keep it short and to the point. 1.06. What is the ratio of the Total Labor Force (in %) of Latin America(developing only) in 1993 to that in 1995?
Give a very brief answer. 0.98. What is the ratio of the Total Labor Force (in %) of Panama in 1993 to that in 1995?
Offer a terse response. 0.99. What is the ratio of the Total Labor Force (in %) in Euro area in 1993 to that in 1996?
Your answer should be compact. 1.08. What is the ratio of the Total Labor Force (in %) in European Union in 1993 to that in 1996?
Keep it short and to the point. 1.08. What is the ratio of the Total Labor Force (in %) in Panama in 1993 to that in 1996?
Offer a very short reply. 0.98. What is the ratio of the Total Labor Force (in %) of Euro area in 1993 to that in 1997?
Offer a terse response. 1.09. What is the ratio of the Total Labor Force (in %) in European Union in 1993 to that in 1997?
Make the answer very short. 1.09. What is the ratio of the Total Labor Force (in %) of Latin America(developing only) in 1993 to that in 1997?
Your answer should be compact. 0.98. What is the ratio of the Total Labor Force (in %) of Panama in 1993 to that in 1997?
Your answer should be compact. 0.97. What is the ratio of the Total Labor Force (in %) of Euro area in 1994 to that in 1995?
Offer a terse response. 1.03. What is the ratio of the Total Labor Force (in %) in European Union in 1994 to that in 1995?
Ensure brevity in your answer.  1.03. What is the ratio of the Total Labor Force (in %) in Latin America(developing only) in 1994 to that in 1995?
Provide a short and direct response. 0.99. What is the ratio of the Total Labor Force (in %) of Euro area in 1994 to that in 1996?
Your answer should be very brief. 1.05. What is the ratio of the Total Labor Force (in %) of European Union in 1994 to that in 1996?
Give a very brief answer. 1.05. What is the ratio of the Total Labor Force (in %) in Euro area in 1994 to that in 1997?
Your response must be concise. 1.06. What is the ratio of the Total Labor Force (in %) in European Union in 1994 to that in 1997?
Provide a succinct answer. 1.06. What is the ratio of the Total Labor Force (in %) of Latin America(developing only) in 1994 to that in 1997?
Provide a succinct answer. 0.99. What is the ratio of the Total Labor Force (in %) of Panama in 1994 to that in 1997?
Make the answer very short. 0.98. What is the ratio of the Total Labor Force (in %) in Euro area in 1995 to that in 1996?
Your response must be concise. 1.02. What is the ratio of the Total Labor Force (in %) of European Union in 1995 to that in 1996?
Make the answer very short. 1.02. What is the ratio of the Total Labor Force (in %) of Latin America(developing only) in 1995 to that in 1996?
Keep it short and to the point. 1.02. What is the ratio of the Total Labor Force (in %) in Panama in 1995 to that in 1996?
Provide a short and direct response. 0.99. What is the ratio of the Total Labor Force (in %) of Euro area in 1995 to that in 1997?
Give a very brief answer. 1.03. What is the ratio of the Total Labor Force (in %) of European Union in 1995 to that in 1997?
Offer a very short reply. 1.03. What is the ratio of the Total Labor Force (in %) of Latin America(developing only) in 1995 to that in 1997?
Provide a succinct answer. 1. What is the ratio of the Total Labor Force (in %) of Panama in 1995 to that in 1997?
Your answer should be compact. 0.98. What is the ratio of the Total Labor Force (in %) of Euro area in 1996 to that in 1997?
Provide a short and direct response. 1.01. What is the ratio of the Total Labor Force (in %) in European Union in 1996 to that in 1997?
Make the answer very short. 1.01. What is the ratio of the Total Labor Force (in %) in Latin America(developing only) in 1996 to that in 1997?
Make the answer very short. 0.99. What is the ratio of the Total Labor Force (in %) of Panama in 1996 to that in 1997?
Your answer should be very brief. 0.99. What is the difference between the highest and the second highest Total Labor Force (in %) of Euro area?
Provide a succinct answer. 2.02. What is the difference between the highest and the second highest Total Labor Force (in %) of European Union?
Your answer should be very brief. 1.87. What is the difference between the highest and the second highest Total Labor Force (in %) in Latin America(developing only)?
Provide a succinct answer. 0.11. What is the difference between the highest and the second highest Total Labor Force (in %) of Panama?
Offer a very short reply. 0.3. What is the difference between the highest and the lowest Total Labor Force (in %) in Euro area?
Keep it short and to the point. 7. What is the difference between the highest and the lowest Total Labor Force (in %) in European Union?
Provide a succinct answer. 7.58. What is the difference between the highest and the lowest Total Labor Force (in %) of Latin America(developing only)?
Make the answer very short. 2.38. What is the difference between the highest and the lowest Total Labor Force (in %) in Panama?
Keep it short and to the point. 2.9. 